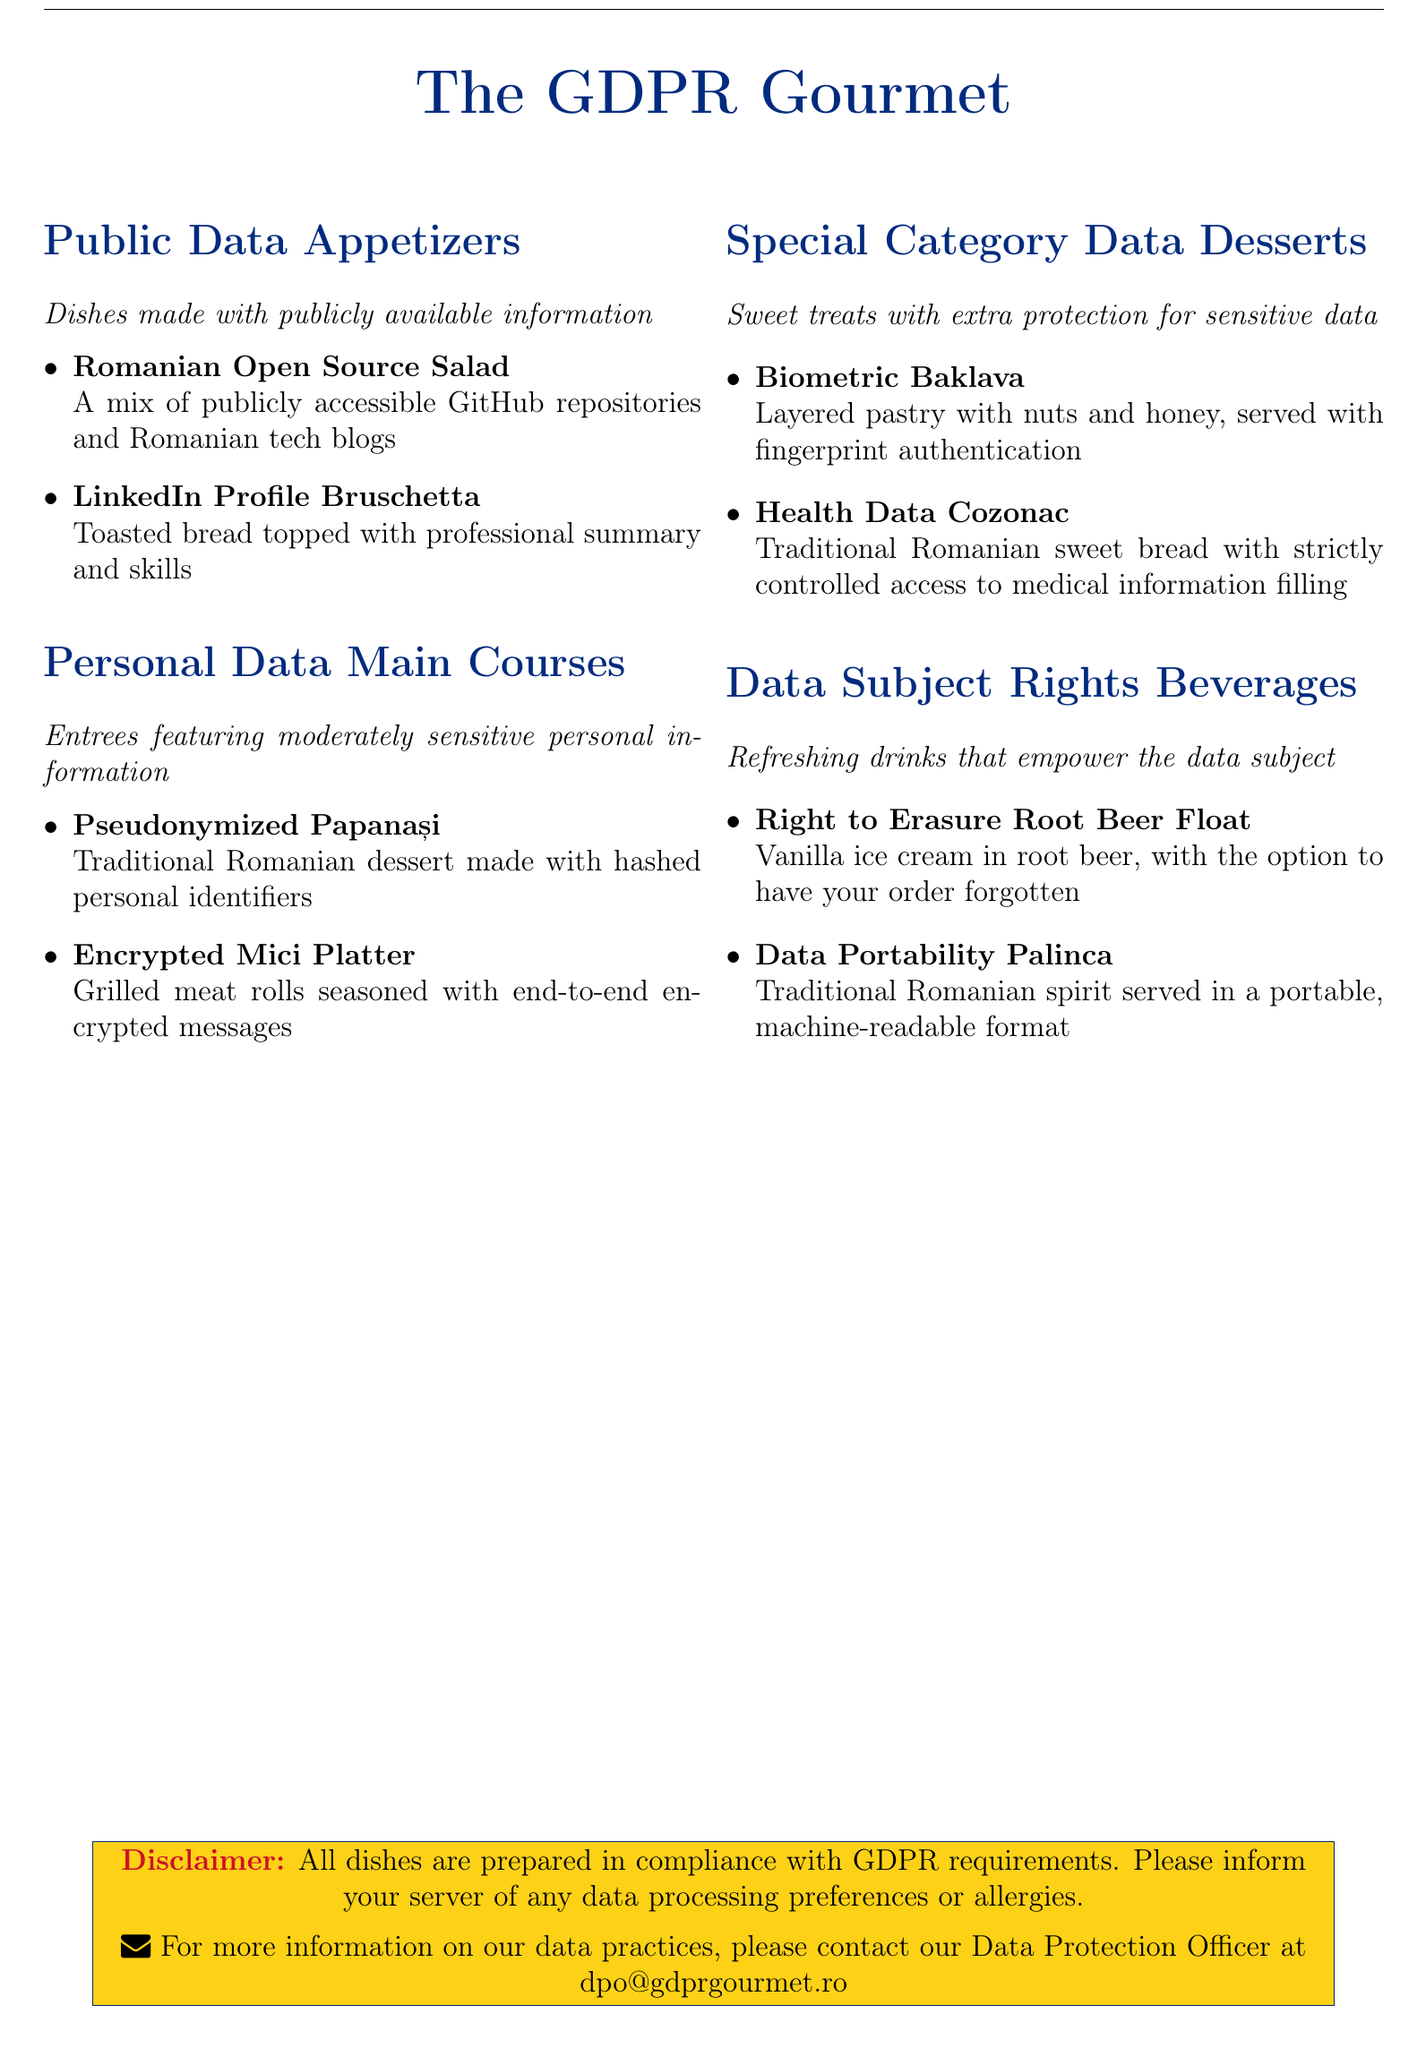what is the title of the menu? The title of the menu is prominently displayed at the top of the document.
Answer: The GDPR Gourmet how many categories of dishes are there? The document divides dishes into four distinct categories.
Answer: 4 what dish is made with publicly accessible information? This dish is highlighted in the Public Data Appetizers section.
Answer: Romanian Open Source Salad what traditional dessert includes hashed personal identifiers? This dish is mentioned in the Personal Data Main Courses section.
Answer: Pseudonymized Papanași what kind of drink provides the option to have your order forgotten? This drink is listed in the Data Subject Rights Beverages section.
Answer: Right to Erasure Root Beer Float which dessert includes fingerprint authentication? This dessert is categorized under Special Category Data Desserts.
Answer: Biometric Baklava what color is the disclaimer box? The color of the disclaimer box is identified through the document's design elements.
Answer: Yellow what is the contact email for the Data Protection Officer? The email address is displayed in the disclaimer section for inquiries.
Answer: dpo@gdprgourmet.ro 